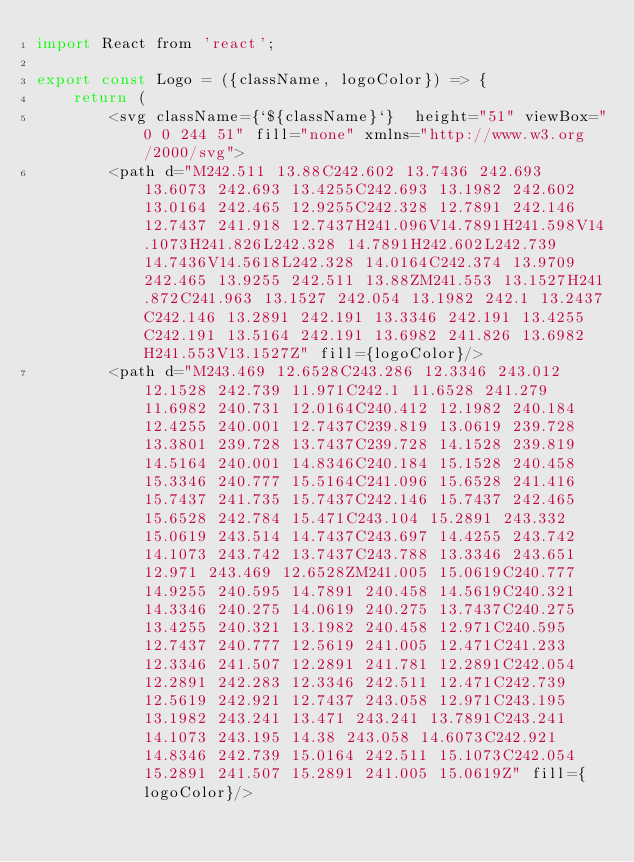<code> <loc_0><loc_0><loc_500><loc_500><_JavaScript_>import React from 'react';

export const Logo = ({className, logoColor}) => {
    return (    
        <svg className={`${className}`}  height="51" viewBox="0 0 244 51" fill="none" xmlns="http://www.w3.org/2000/svg">
        <path d="M242.511 13.88C242.602 13.7436 242.693 13.6073 242.693 13.4255C242.693 13.1982 242.602 13.0164 242.465 12.9255C242.328 12.7891 242.146 12.7437 241.918 12.7437H241.096V14.7891H241.598V14.1073H241.826L242.328 14.7891H242.602L242.739 14.7436V14.5618L242.328 14.0164C242.374 13.9709 242.465 13.9255 242.511 13.88ZM241.553 13.1527H241.872C241.963 13.1527 242.054 13.1982 242.1 13.2437C242.146 13.2891 242.191 13.3346 242.191 13.4255C242.191 13.5164 242.191 13.6982 241.826 13.6982H241.553V13.1527Z" fill={logoColor}/>
        <path d="M243.469 12.6528C243.286 12.3346 243.012 12.1528 242.739 11.971C242.1 11.6528 241.279 11.6982 240.731 12.0164C240.412 12.1982 240.184 12.4255 240.001 12.7437C239.819 13.0619 239.728 13.3801 239.728 13.7437C239.728 14.1528 239.819 14.5164 240.001 14.8346C240.184 15.1528 240.458 15.3346 240.777 15.5164C241.096 15.6528 241.416 15.7437 241.735 15.7437C242.146 15.7437 242.465 15.6528 242.784 15.471C243.104 15.2891 243.332 15.0619 243.514 14.7437C243.697 14.4255 243.742 14.1073 243.742 13.7437C243.788 13.3346 243.651 12.971 243.469 12.6528ZM241.005 15.0619C240.777 14.9255 240.595 14.7891 240.458 14.5619C240.321 14.3346 240.275 14.0619 240.275 13.7437C240.275 13.4255 240.321 13.1982 240.458 12.971C240.595 12.7437 240.777 12.5619 241.005 12.471C241.233 12.3346 241.507 12.2891 241.781 12.2891C242.054 12.2891 242.283 12.3346 242.511 12.471C242.739 12.5619 242.921 12.7437 243.058 12.971C243.195 13.1982 243.241 13.471 243.241 13.7891C243.241 14.1073 243.195 14.38 243.058 14.6073C242.921 14.8346 242.739 15.0164 242.511 15.1073C242.054 15.2891 241.507 15.2891 241.005 15.0619Z" fill={logoColor}/></code> 